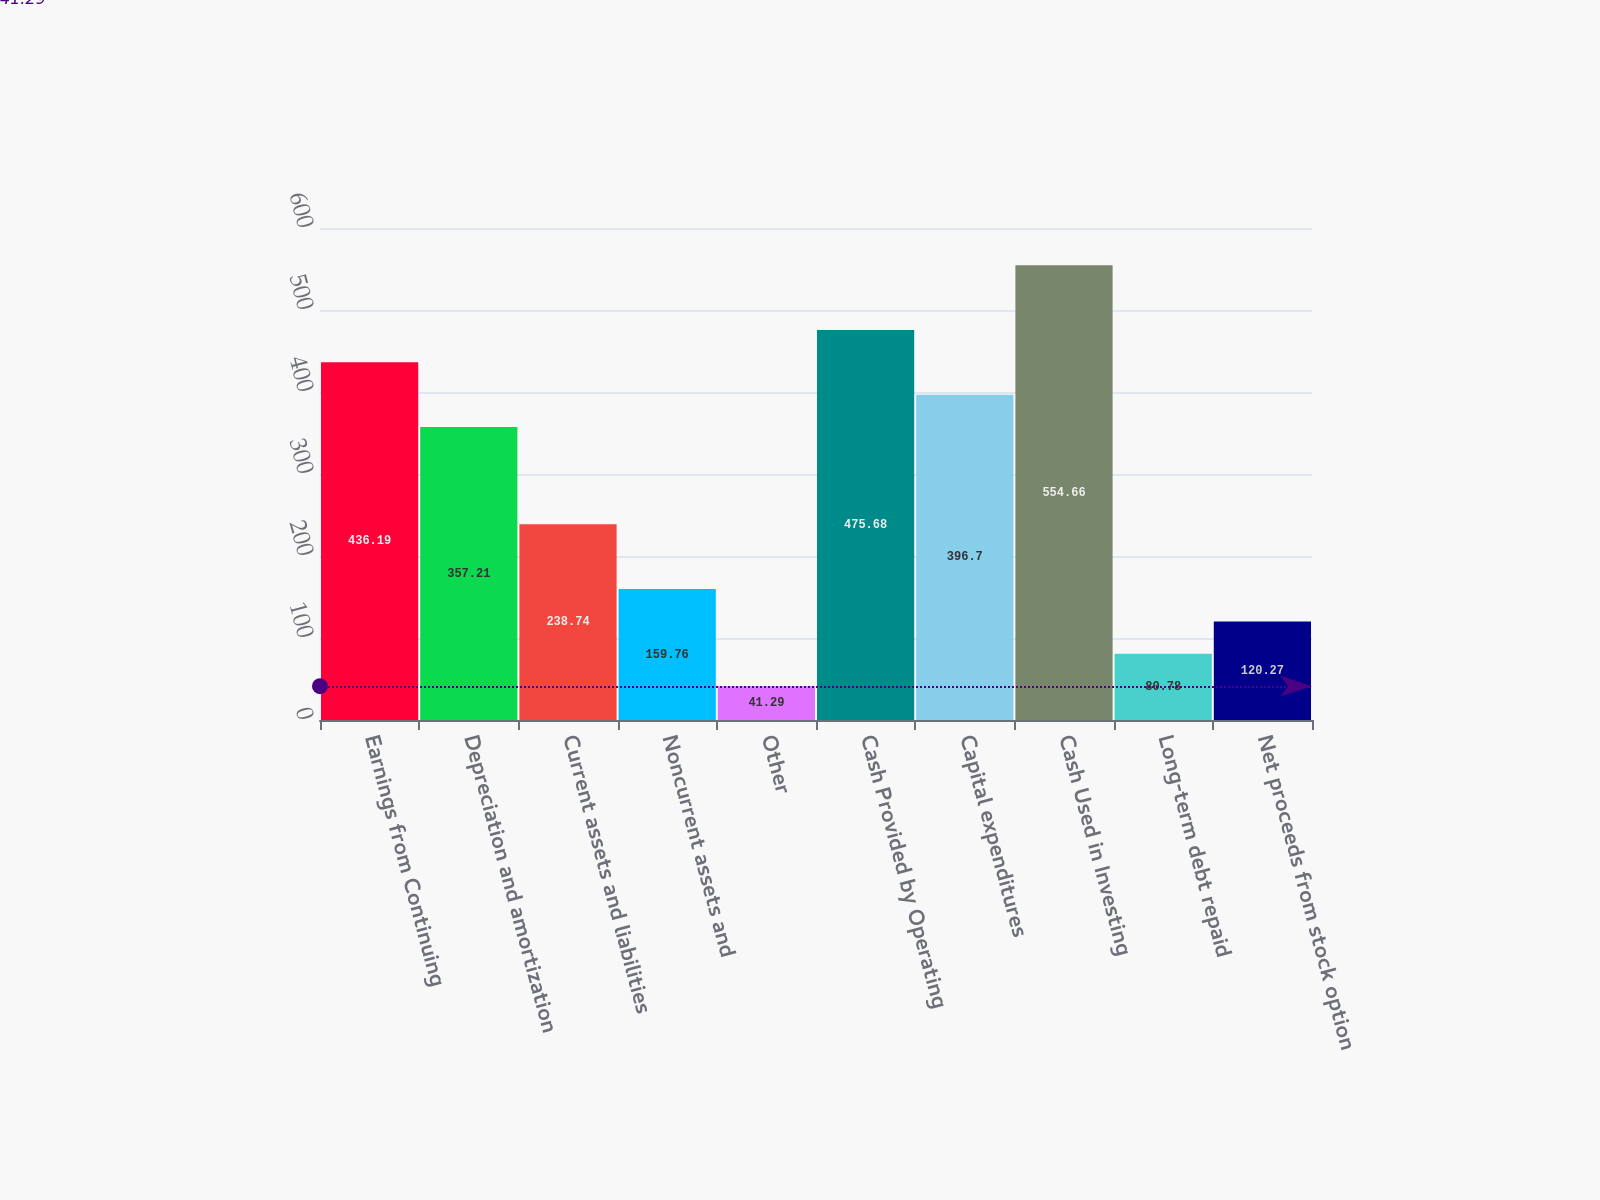Convert chart to OTSL. <chart><loc_0><loc_0><loc_500><loc_500><bar_chart><fcel>Earnings from Continuing<fcel>Depreciation and amortization<fcel>Current assets and liabilities<fcel>Noncurrent assets and<fcel>Other<fcel>Cash Provided by Operating<fcel>Capital expenditures<fcel>Cash Used in Investing<fcel>Long-term debt repaid<fcel>Net proceeds from stock option<nl><fcel>436.19<fcel>357.21<fcel>238.74<fcel>159.76<fcel>41.29<fcel>475.68<fcel>396.7<fcel>554.66<fcel>80.78<fcel>120.27<nl></chart> 